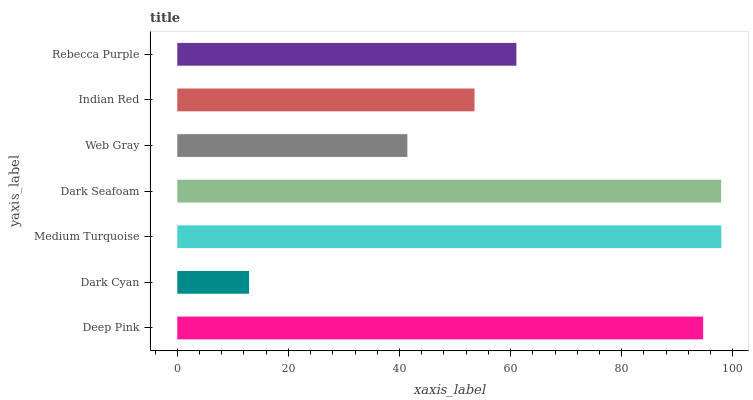Is Dark Cyan the minimum?
Answer yes or no. Yes. Is Medium Turquoise the maximum?
Answer yes or no. Yes. Is Medium Turquoise the minimum?
Answer yes or no. No. Is Dark Cyan the maximum?
Answer yes or no. No. Is Medium Turquoise greater than Dark Cyan?
Answer yes or no. Yes. Is Dark Cyan less than Medium Turquoise?
Answer yes or no. Yes. Is Dark Cyan greater than Medium Turquoise?
Answer yes or no. No. Is Medium Turquoise less than Dark Cyan?
Answer yes or no. No. Is Rebecca Purple the high median?
Answer yes or no. Yes. Is Rebecca Purple the low median?
Answer yes or no. Yes. Is Dark Cyan the high median?
Answer yes or no. No. Is Dark Seafoam the low median?
Answer yes or no. No. 